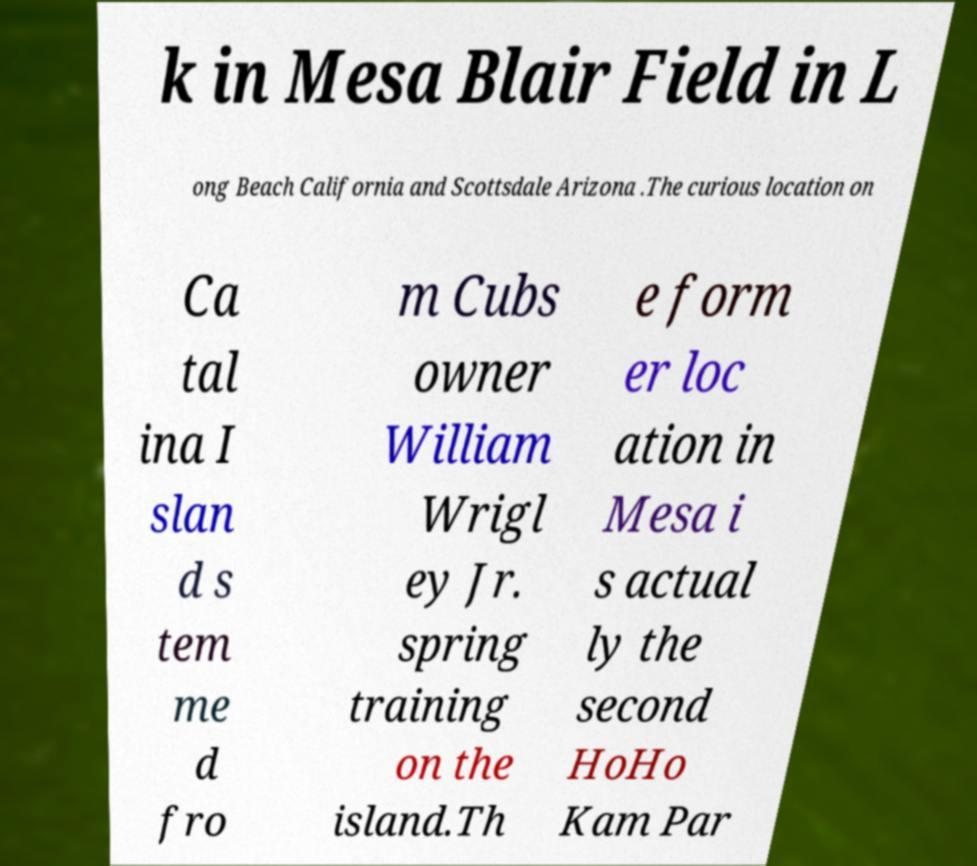Please identify and transcribe the text found in this image. k in Mesa Blair Field in L ong Beach California and Scottsdale Arizona .The curious location on Ca tal ina I slan d s tem me d fro m Cubs owner William Wrigl ey Jr. spring training on the island.Th e form er loc ation in Mesa i s actual ly the second HoHo Kam Par 